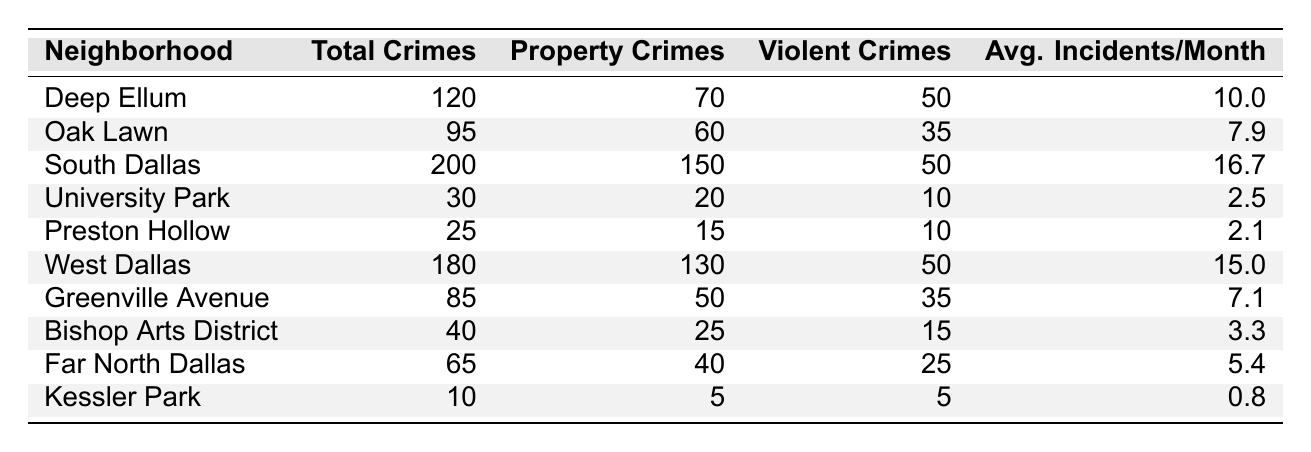What neighborhood in Dallas had the highest total crimes in 2022? By reviewing the "Total Crimes" column in the table, South Dallas has the highest total with 200 crimes reported.
Answer: South Dallas How many violent crimes were reported in Oak Lawn? The table indicates that Oak Lawn has 35 violent crimes listed under the "Violent Crimes" column.
Answer: 35 Which neighborhood had the lowest average incidents per month? Kessler Park has the lowest average incidents per month with a value of 0.8.
Answer: Kessler Park What is the total number of violent crimes in West Dallas and South Dallas combined? Adding the violent crimes from West Dallas (50) and South Dallas (50) gives a total of 100 violent crimes (50 + 50 = 100).
Answer: 100 Is the total number of property crimes in the Bishop Arts District more than that in University Park? The Bishop Arts District reports 25 property crimes, while University Park reports 20. Since 25 is greater than 20, the statement is true.
Answer: Yes What is the average number of total crimes per neighborhood in the provided data? To find the average, first sum the total crimes: 120 + 95 + 200 + 30 + 25 + 180 + 85 + 40 + 65 + 10 = 1,000 crimes. There are 10 neighborhoods, so the average is 1,000 / 10 = 100.
Answer: 100 Which neighborhood had a total crime count higher than 100 but less than 200? Looking at the "Total Crimes" column, West Dallas (180) falls between 100 and 200 while South Dallas (200) exceeds this limit. Therefore, the answer is West Dallas.
Answer: West Dallas If you compare Greenville Avenue and Oak Lawn, which neighborhood had fewer total crimes? Greenville Avenue has 85 total crimes while Oak Lawn has 95. Since 85 is less than 95, Greenville Avenue had fewer total crimes.
Answer: Greenville Avenue What percentage of the total crimes in South Dallas were property crimes? South Dallas has 200 total crimes with 150 being property crimes. The percentage is calculated as (150 / 200) * 100 = 75%.
Answer: 75% Calculate the difference in average incidents per month between Deep Ellum and Preston Hollow. Deep Ellum has 10.0 average incidents per month, and Preston Hollow has 2.1. The difference is 10.0 - 2.1 = 7.9.
Answer: 7.9 